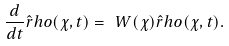Convert formula to latex. <formula><loc_0><loc_0><loc_500><loc_500>\frac { d } { d t } \hat { r } h o ( \chi , t ) = \ W ( \chi ) \hat { r } h o ( \chi , t ) .</formula> 